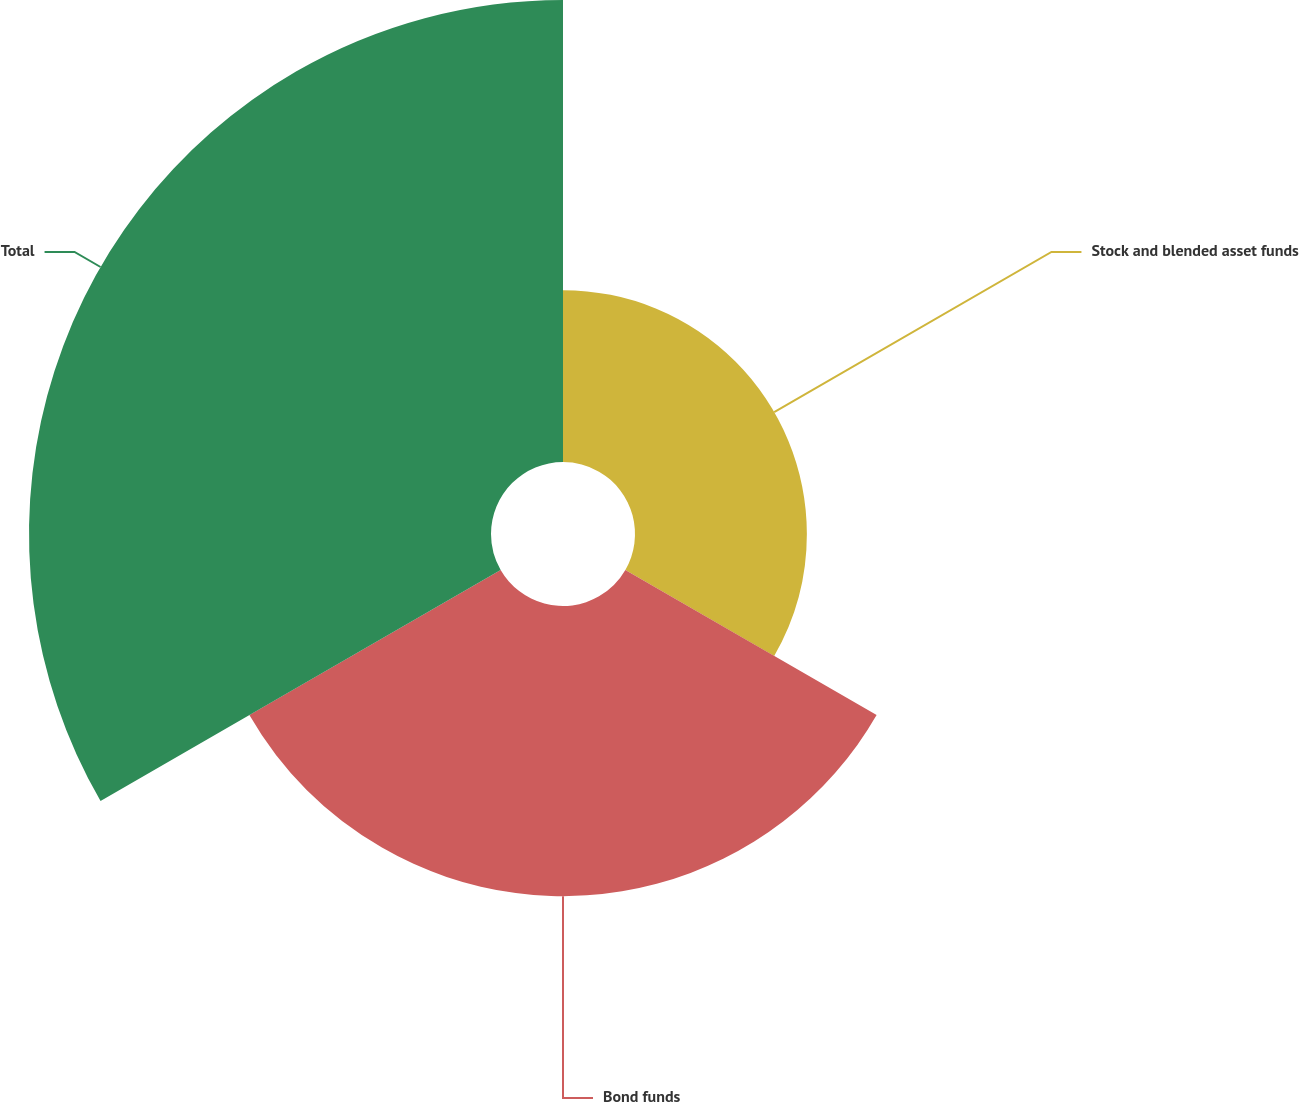Convert chart. <chart><loc_0><loc_0><loc_500><loc_500><pie_chart><fcel>Stock and blended asset funds<fcel>Bond funds<fcel>Total<nl><fcel>18.6%<fcel>31.4%<fcel>50.0%<nl></chart> 